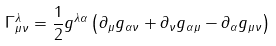<formula> <loc_0><loc_0><loc_500><loc_500>\Gamma _ { \mu \nu } ^ { \lambda } = \frac { 1 } { 2 } g ^ { \lambda \alpha } \left ( \partial _ { \mu } g _ { \alpha \nu } + \partial _ { \nu } g _ { \alpha \mu } - \partial _ { \alpha } g _ { \mu \nu } \right )</formula> 